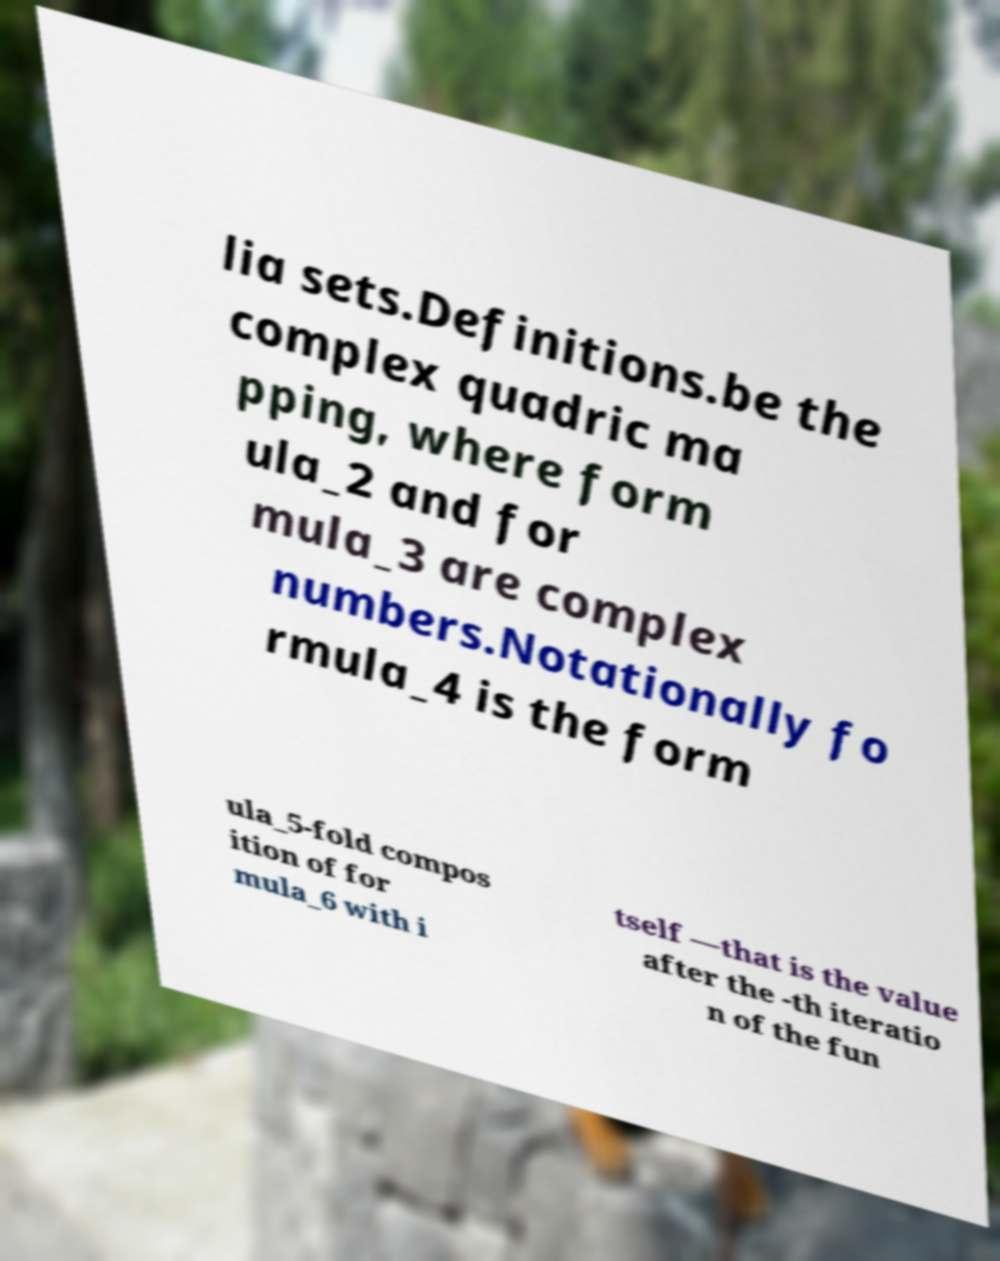What messages or text are displayed in this image? I need them in a readable, typed format. lia sets.Definitions.be the complex quadric ma pping, where form ula_2 and for mula_3 are complex numbers.Notationally fo rmula_4 is the form ula_5-fold compos ition of for mula_6 with i tself —that is the value after the -th iteratio n of the fun 